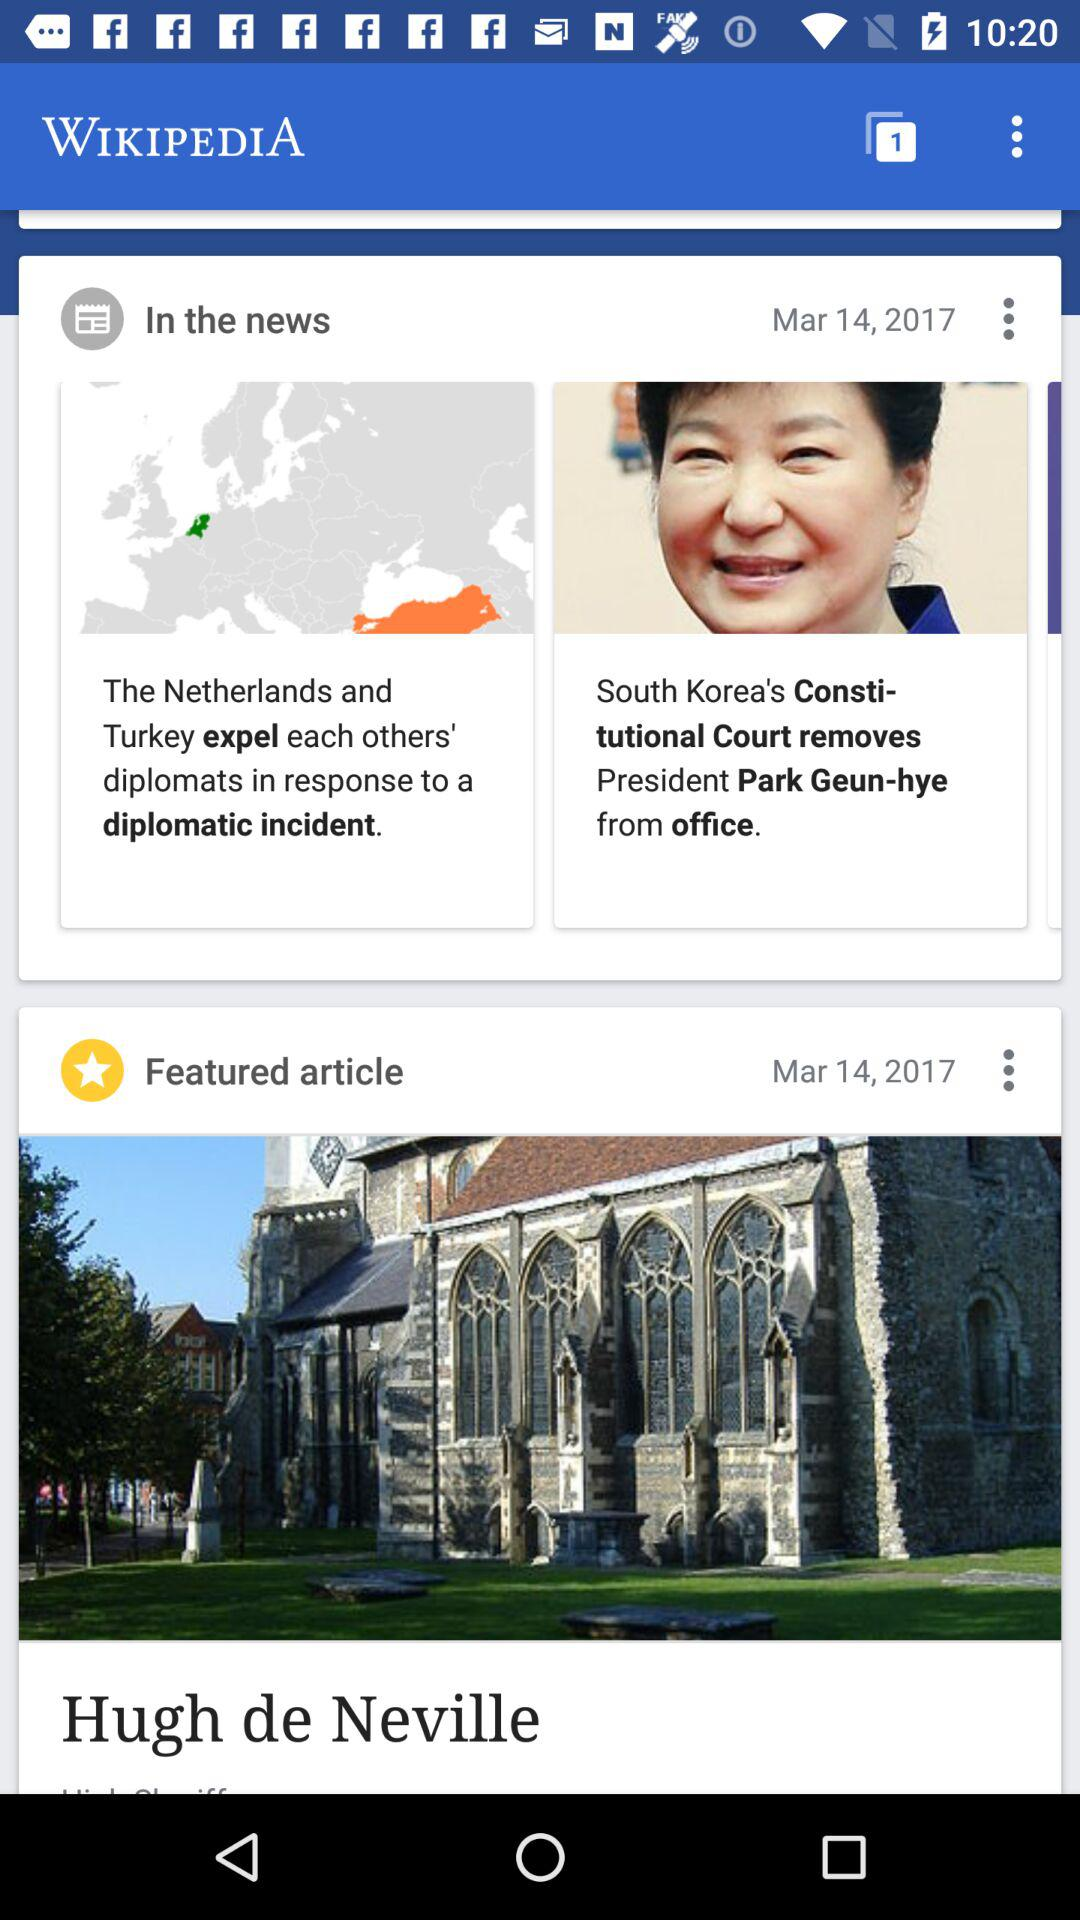What is the date when the featured article was updated? The date is March 14, 2017. 